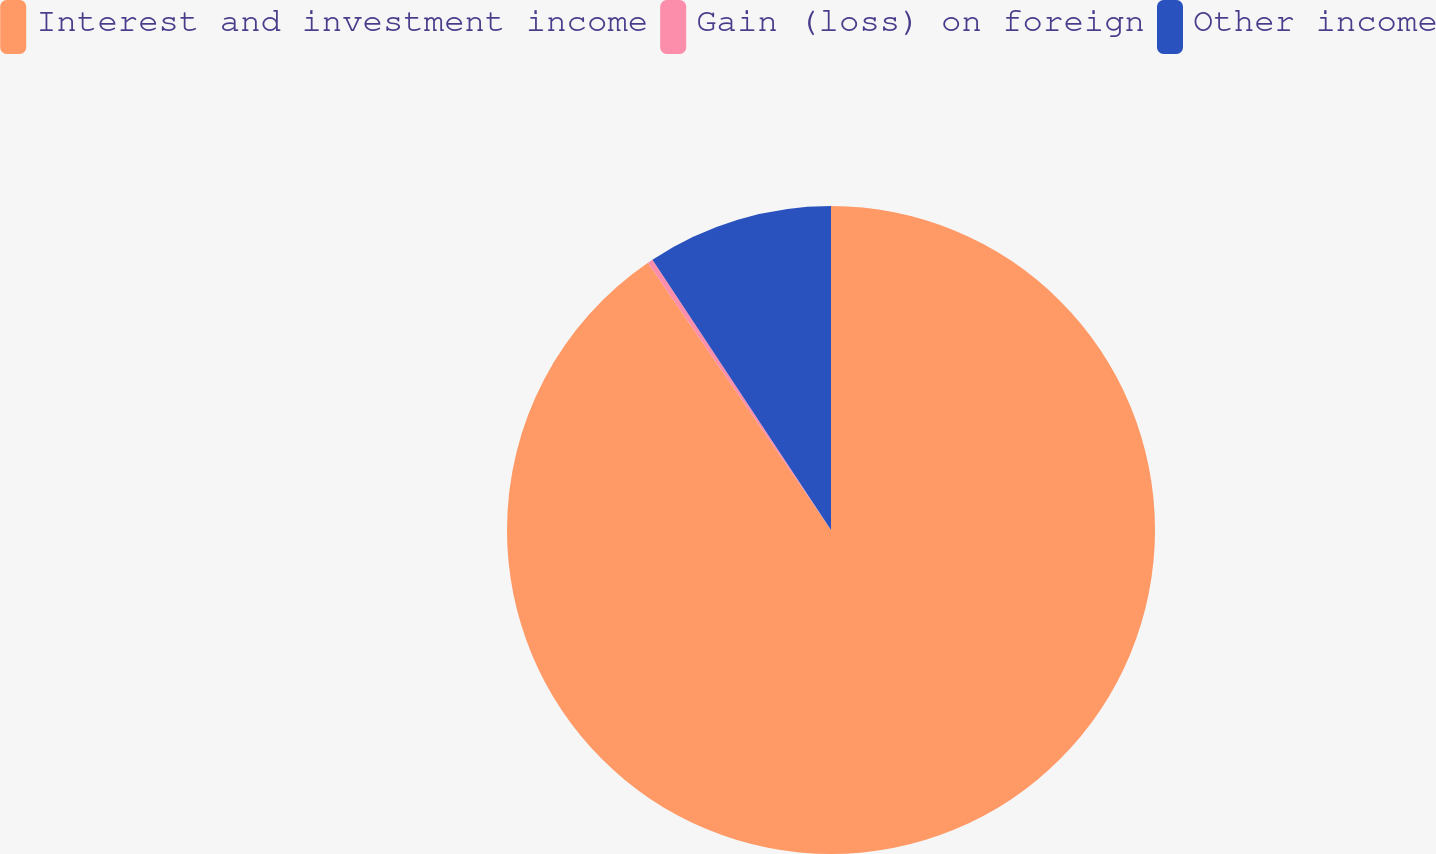<chart> <loc_0><loc_0><loc_500><loc_500><pie_chart><fcel>Interest and investment income<fcel>Gain (loss) on foreign<fcel>Other income<nl><fcel>90.44%<fcel>0.27%<fcel>9.29%<nl></chart> 